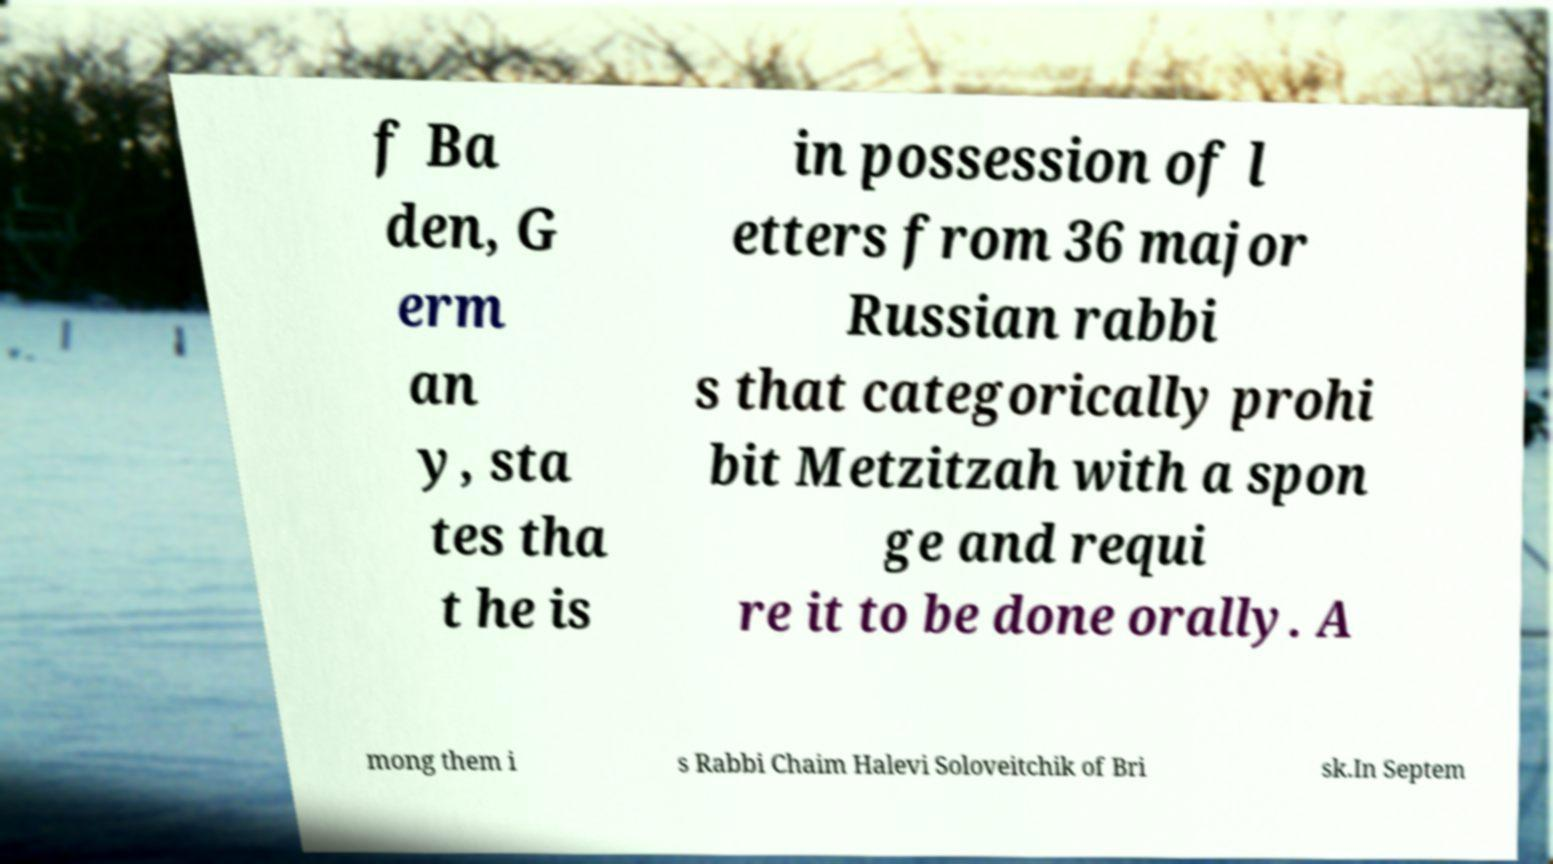What messages or text are displayed in this image? I need them in a readable, typed format. f Ba den, G erm an y, sta tes tha t he is in possession of l etters from 36 major Russian rabbi s that categorically prohi bit Metzitzah with a spon ge and requi re it to be done orally. A mong them i s Rabbi Chaim Halevi Soloveitchik of Bri sk.In Septem 